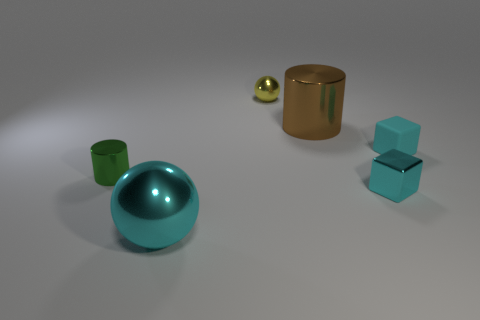What number of large cyan things are there?
Your answer should be compact. 1. Is there a yellow object that has the same material as the tiny green cylinder?
Ensure brevity in your answer.  Yes. There is a ball that is the same color as the rubber object; what is its size?
Make the answer very short. Large. Does the cyan cube in front of the tiny green metallic thing have the same size as the cyan metallic ball in front of the brown object?
Keep it short and to the point. No. What is the size of the shiny cylinder to the right of the green thing?
Provide a succinct answer. Large. Are there any tiny rubber objects that have the same color as the shiny block?
Keep it short and to the point. Yes. There is a large thing that is on the left side of the yellow metal thing; are there any things right of it?
Make the answer very short. Yes. Do the cyan rubber thing and the shiny cylinder on the right side of the large cyan shiny sphere have the same size?
Your answer should be compact. No. Is there a cyan block that is in front of the shiny cylinder that is on the left side of the large shiny thing that is in front of the big brown metal cylinder?
Offer a very short reply. Yes. There is a ball behind the shiny cube; what material is it?
Provide a succinct answer. Metal. 